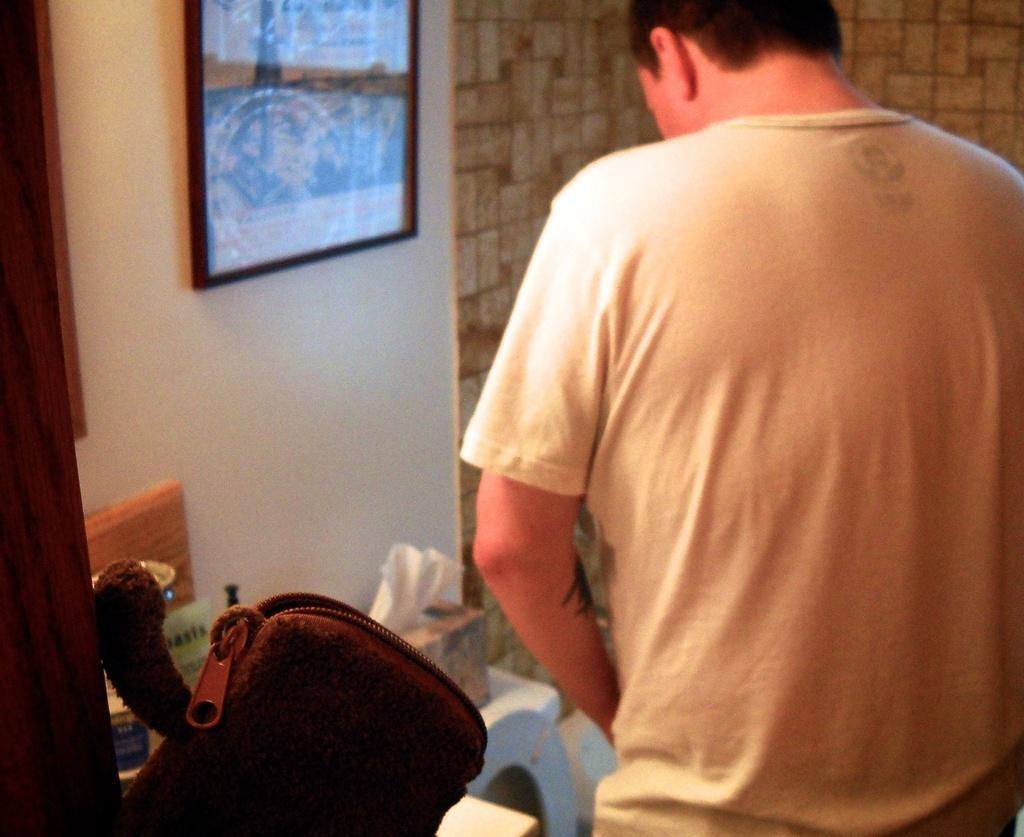Describe this image in one or two sentences. In this picture we can see a person turn around and standing in front of a commode. Here we an see tissues, a bag & a photo frame. 